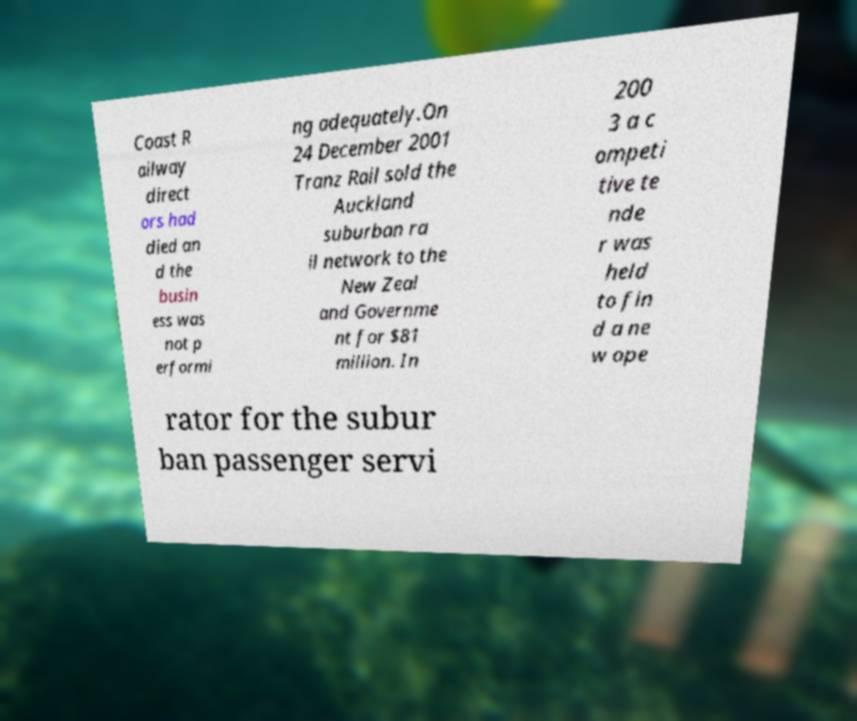There's text embedded in this image that I need extracted. Can you transcribe it verbatim? Coast R ailway direct ors had died an d the busin ess was not p erformi ng adequately.On 24 December 2001 Tranz Rail sold the Auckland suburban ra il network to the New Zeal and Governme nt for $81 million. In 200 3 a c ompeti tive te nde r was held to fin d a ne w ope rator for the subur ban passenger servi 